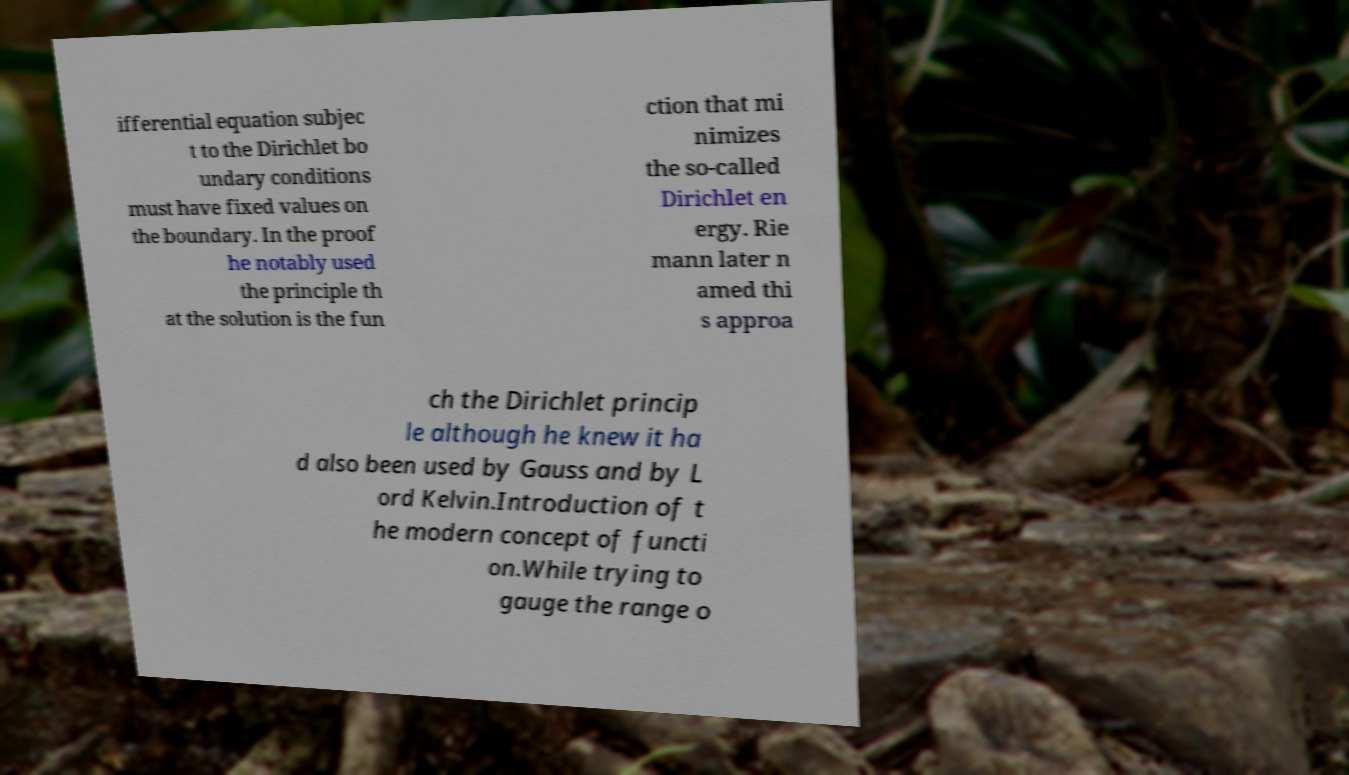Please read and relay the text visible in this image. What does it say? ifferential equation subjec t to the Dirichlet bo undary conditions must have fixed values on the boundary. In the proof he notably used the principle th at the solution is the fun ction that mi nimizes the so-called Dirichlet en ergy. Rie mann later n amed thi s approa ch the Dirichlet princip le although he knew it ha d also been used by Gauss and by L ord Kelvin.Introduction of t he modern concept of functi on.While trying to gauge the range o 